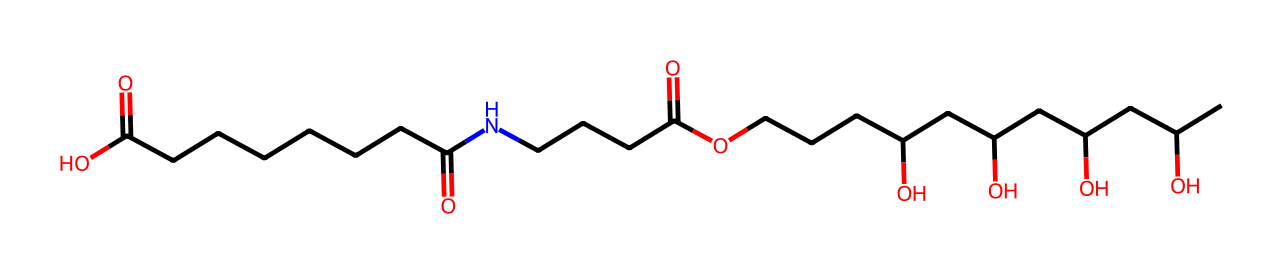what is the total number of carbon atoms in this chemical? To determine the total number of carbon atoms, we can count the number of "C" occurrences in the SMILES representation. By analyzing the structure, there are 21 carbon symbols (C) present.
Answer: 21 how many carboxylic acid groups are present in this molecule? We need to identify the -COOH (carboxylic acid) functional groups in the structure. In the given SMILES, there are two instances of "C(=O)O," representing two carboxylic acid groups.
Answer: 2 what type of chemical is represented by this structure? Looking at the structure indicates the presence of long carbon chains with carboxylic acid (-COOH) and amide (-CONH-) groups, suggesting that this is a type of biodegradable polymer.
Answer: biodegradable polymer how many hydrogen atoms can be inferred from this chemical structure? To estimate hydrogen atoms, we consider the tetravalent nature of carbon, where each carbon typically forms four bonds. Given the number of carbon, oxygen, and nitrogen atoms, we apply the general counting rule for hydrogens in aliphatic compounds. Upon calculating, it infers approximately 42 hydrogen atoms.
Answer: 42 does this chemical contain any halogens? A search through the SMILES representation reveals that there are no halogen atoms (like F, Cl, Br, I) present in the molecule, which focuses on carbon, oxygen, and nitrogen atoms instead.
Answer: no what functional groups are present in this structure? By analyzing the SMILES, we can identify that the chemical contains carboxylic acid (-COOH) groups, an amide (-CONH), and hydroxyl (-OH) groups. Each of these groups is vital for its properties.
Answer: carboxylic acid, amide, hydroxyl how would this structure impact its biodegradability? The presence of multiple -COOH and -OH groups enhances the water solubility and allows for microbial breakdown. The structural components suggest that it is likely to be biodegradable due to these functional groups and the long carbon chain structure.
Answer: likely biodegradable 